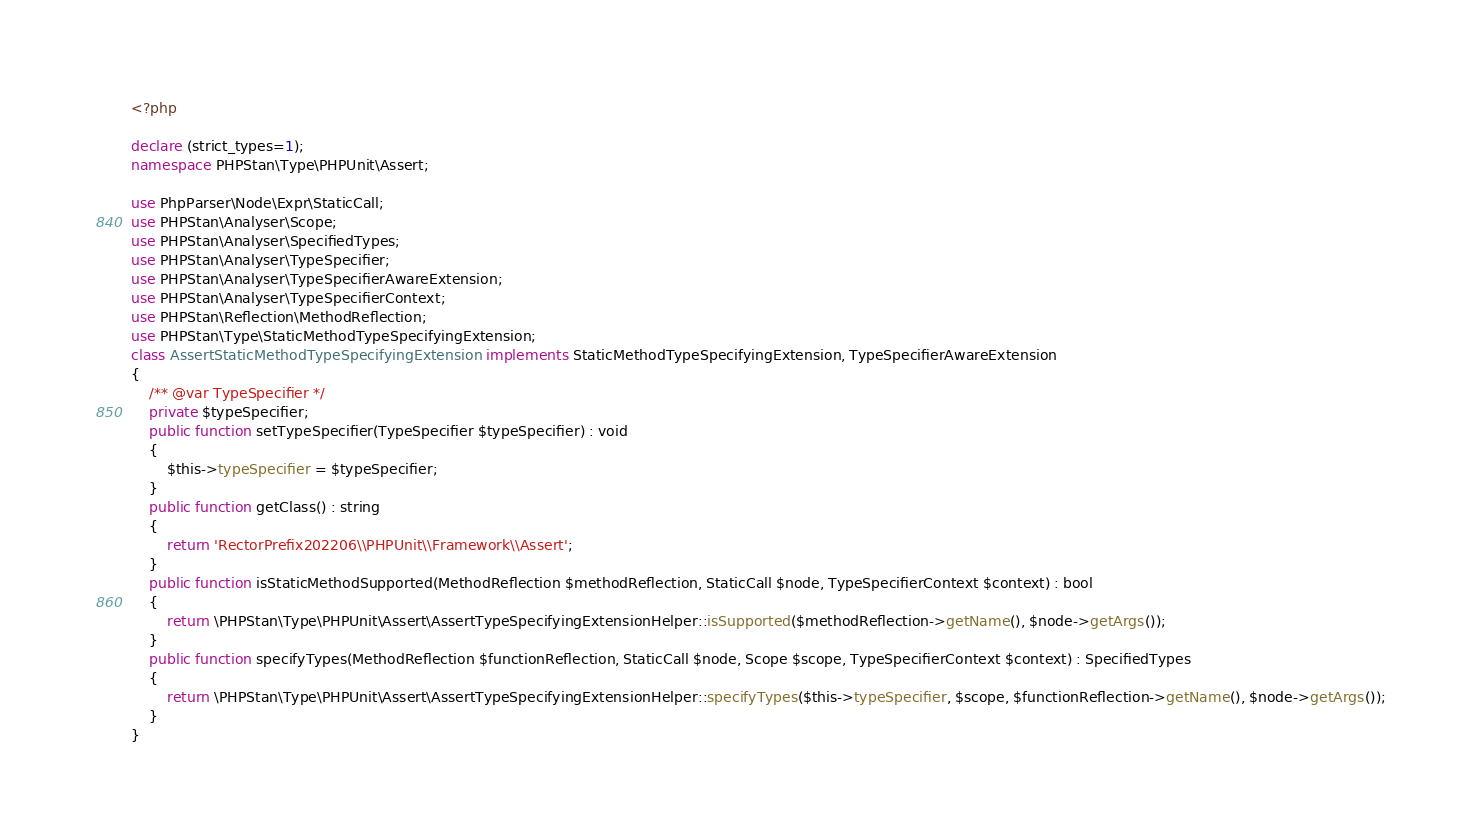<code> <loc_0><loc_0><loc_500><loc_500><_PHP_><?php

declare (strict_types=1);
namespace PHPStan\Type\PHPUnit\Assert;

use PhpParser\Node\Expr\StaticCall;
use PHPStan\Analyser\Scope;
use PHPStan\Analyser\SpecifiedTypes;
use PHPStan\Analyser\TypeSpecifier;
use PHPStan\Analyser\TypeSpecifierAwareExtension;
use PHPStan\Analyser\TypeSpecifierContext;
use PHPStan\Reflection\MethodReflection;
use PHPStan\Type\StaticMethodTypeSpecifyingExtension;
class AssertStaticMethodTypeSpecifyingExtension implements StaticMethodTypeSpecifyingExtension, TypeSpecifierAwareExtension
{
    /** @var TypeSpecifier */
    private $typeSpecifier;
    public function setTypeSpecifier(TypeSpecifier $typeSpecifier) : void
    {
        $this->typeSpecifier = $typeSpecifier;
    }
    public function getClass() : string
    {
        return 'RectorPrefix202206\\PHPUnit\\Framework\\Assert';
    }
    public function isStaticMethodSupported(MethodReflection $methodReflection, StaticCall $node, TypeSpecifierContext $context) : bool
    {
        return \PHPStan\Type\PHPUnit\Assert\AssertTypeSpecifyingExtensionHelper::isSupported($methodReflection->getName(), $node->getArgs());
    }
    public function specifyTypes(MethodReflection $functionReflection, StaticCall $node, Scope $scope, TypeSpecifierContext $context) : SpecifiedTypes
    {
        return \PHPStan\Type\PHPUnit\Assert\AssertTypeSpecifyingExtensionHelper::specifyTypes($this->typeSpecifier, $scope, $functionReflection->getName(), $node->getArgs());
    }
}
</code> 